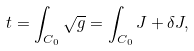<formula> <loc_0><loc_0><loc_500><loc_500>t = \int _ { C _ { 0 } } \sqrt { g } = \int _ { C _ { 0 } } J + \delta J ,</formula> 